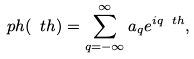<formula> <loc_0><loc_0><loc_500><loc_500>\ p h ( \ t h ) = \sum _ { q = - \infty } ^ { \infty } a _ { q } e ^ { i q \ t h } ,</formula> 